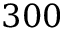<formula> <loc_0><loc_0><loc_500><loc_500>3 0 0</formula> 